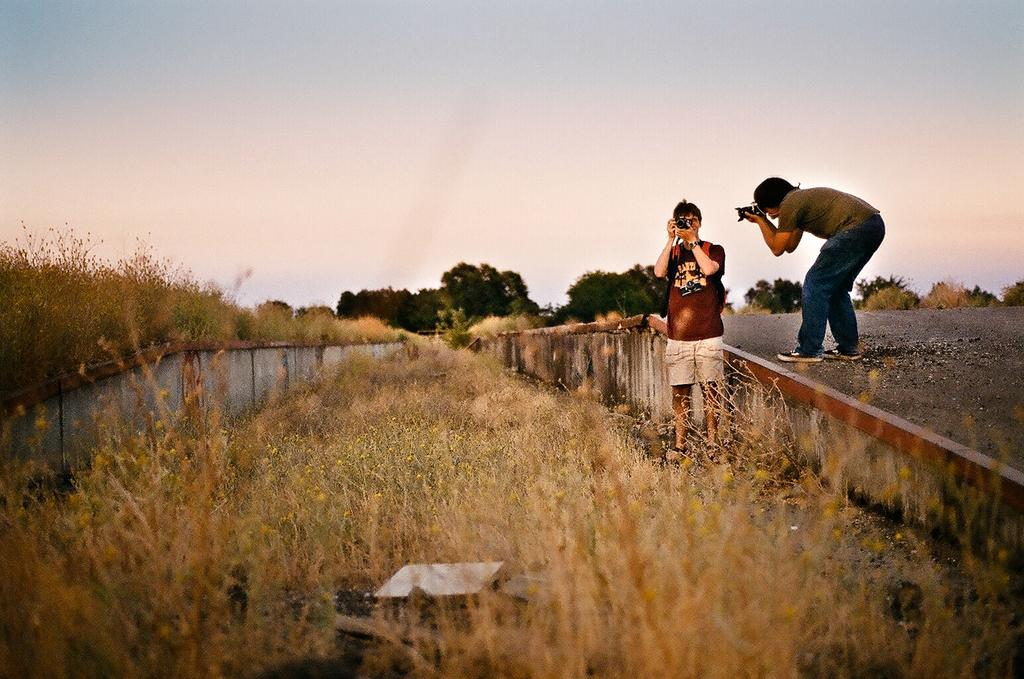How many people are in the image? There are two persons in the image. What are the persons holding in the image? The persons are holding cameras. What can be seen in the background of the image? There is a road, grass, trees, and the sky visible in the image. What type of ornament is hanging from the trees in the image? There is no ornament hanging from the trees in the image; only the trees themselves are visible. What invention can be seen being used by the persons in the image? The persons are holding cameras, but there is no mention of any specific invention in the image. 